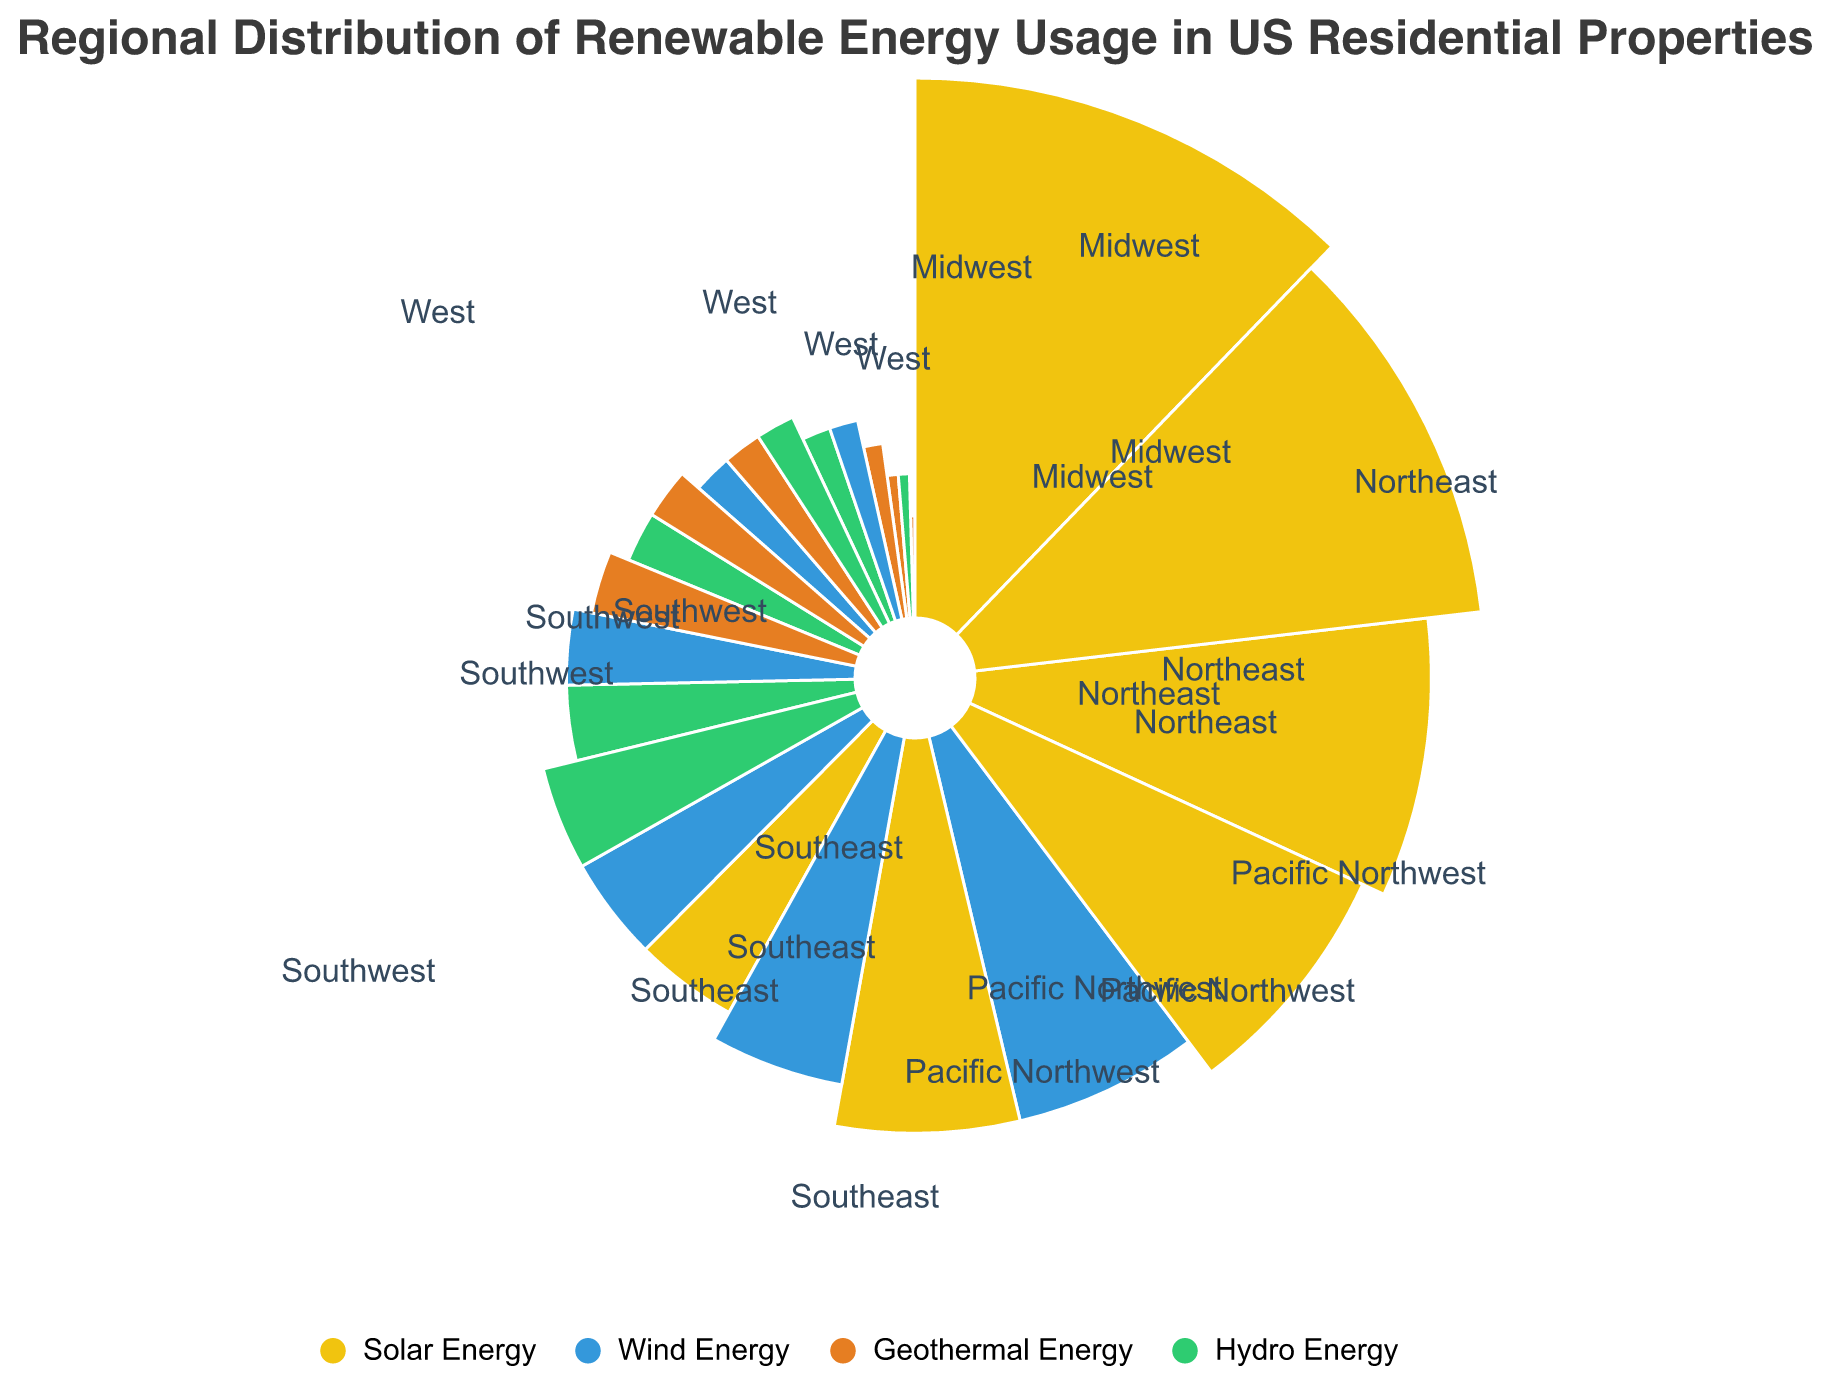What is the title of the figure? The title is usually displayed at the top of the figure. In this case, the title is "Regional Distribution of Renewable Energy Usage in US Residential Properties" as mentioned in the description.
Answer: Regional Distribution of Renewable Energy Usage in US Residential Properties Which region utilizes the most solar energy? Observe the length of the arc segments corresponding to Solar Energy for each region. The Southwest has the longest arc for Solar Energy, indicating the highest usage.
Answer: Southwest Which type of renewable energy has the highest usage in the Northeast? Check the color-coded segments for the Northeast region and compare their lengths. Solar Energy (yellow) has the longest segment, indicating the highest usage.
Answer: Solar Energy How much geothermal energy is utilized in the Pacific Northwest? Geothermal Energy usage for each region is specified in the provided data. For the Pacific Northwest, the value is 7.
Answer: 7 Compare the total usage of hydro energy in the West and Pacific Northwest regions. Which one uses more? Sum up the values of Hydro Energy for both regions. The West uses 5 and the Pacific Northwest uses 10, thus the Pacific Northwest uses more.
Answer: Pacific Northwest What is the average usage of wind energy across all regions? Add the values of Wind Energy for all regions: (5 + 15 + 4 + 8 + 10 + 12) = 54, then divide by the number of regions (6). 54/6 = 9.
Answer: 9 Which region has the lowest combined renewable energy usage? Sum up all the energy types for each region and compare. The Northeast has the combined total of (20 + 5 + 2 + 4) = 31, which is the lowest among all regions.
Answer: Northeast What is the difference in solar energy usage between the Southwest and the Midwest? Subtract the Midwest's solar energy usage from the Southwest's: 28 - 10 = 18.
Answer: 18 Which type of energy does the Midwest use the most? In the Midwest, the highest value among renewable energy types is Wind Energy (15).
Answer: Wind Energy Is the utilization of hydro energy greater in the Southeast or the Northeast? Compare the values for Hydro Energy in both regions. Southeast has 8 and Northeast has 4, so the utilization is greater in the Southeast.
Answer: Southeast 